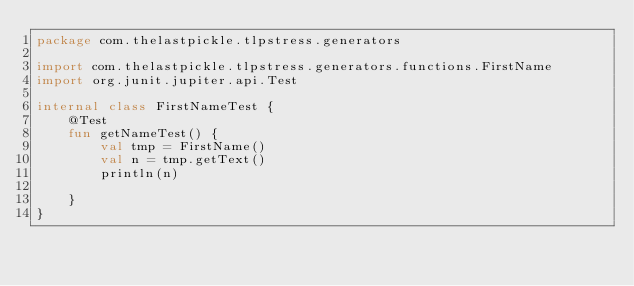Convert code to text. <code><loc_0><loc_0><loc_500><loc_500><_Kotlin_>package com.thelastpickle.tlpstress.generators

import com.thelastpickle.tlpstress.generators.functions.FirstName
import org.junit.jupiter.api.Test

internal class FirstNameTest {
    @Test
    fun getNameTest() {
        val tmp = FirstName()
        val n = tmp.getText()
        println(n)

    }
}</code> 